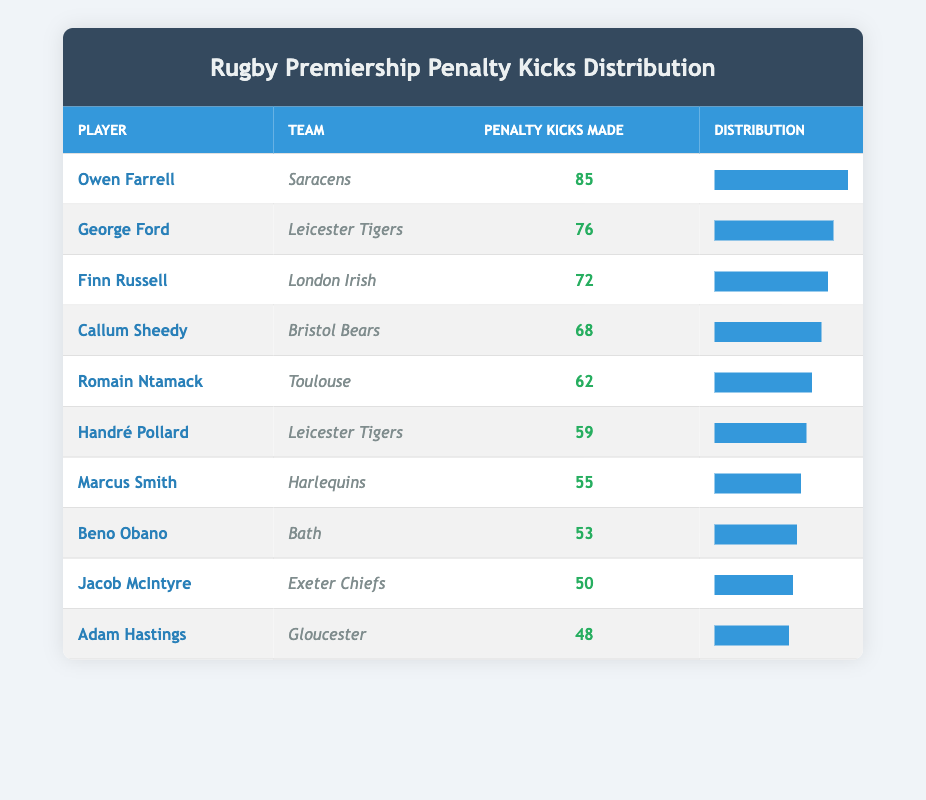What is the highest number of penalty kicks made by a player? The table shows that Owen Farrell made 85 penalty kicks, which is the highest among all players listed.
Answer: 85 Who is the player with the lowest number of penalty kicks made? Adam Hastings made 48 penalty kicks, which is the lowest in the table.
Answer: Adam Hastings Calculate the average number of penalty kicks made by the players listed. The total number of penalty kicks made by all players is (85 + 76 + 72 + 68 + 62 + 59 + 55 + 53 + 50 + 48) =  654. There are 10 players, so the average is 654/10 = 65.4.
Answer: 65.4 Is George Ford’s penalty kicks made more than Marcus Smith's? George Ford made 76 penalty kicks while Marcus Smith made 55, therefore George Ford’s penalty kicks are indeed more.
Answer: Yes How many players made more than 60 penalty kicks? Referring to the table, the players with penalty kicks above 60 are Owen Farrell, George Ford, Finn Russell, Callum Sheedy, and Romain Ntamack, totaling 5 players.
Answer: 5 What is the difference between the highest and the lowest number of penalty kicks made? The highest is 85 (Owen Farrell) and the lowest is 48 (Adam Hastings), therefore the difference is 85 - 48 = 37.
Answer: 37 Which team has the most players listed in the table? Leicester Tigers has two players listed (George Ford and Handré Pollard), while all other teams only have one player, making Leicester Tigers the team with the most players in the table.
Answer: Leicester Tigers Calculate the median of the penalty kicks made by players. First, arrange the penalty kicks made in ascending order: 48, 50, 53, 55, 59, 62, 68, 72, 76, 85. With 10 values, the median is the average of the 5th and 6th values: (59+62)/2 = 60.5.
Answer: 60.5 